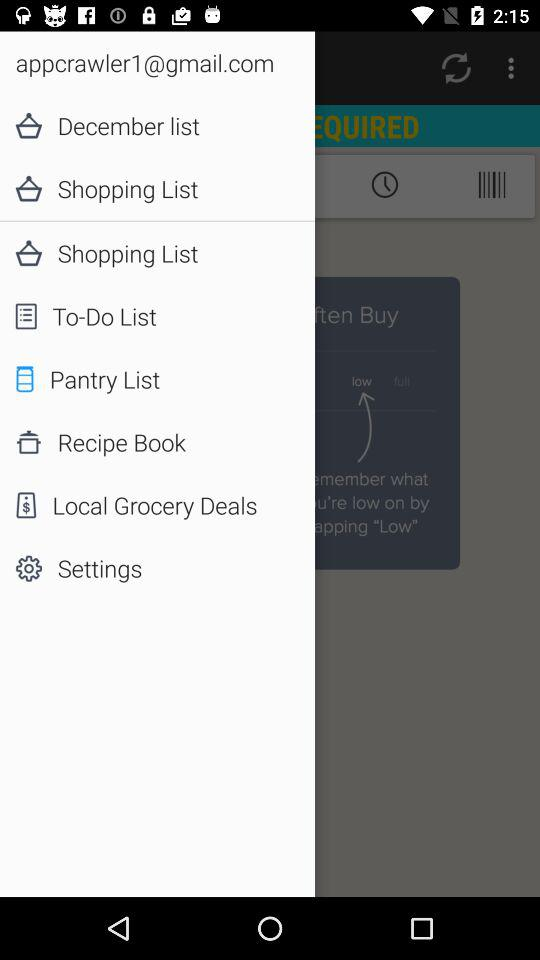What is the email ID? The email ID is appcrawler1@gmail.com. 